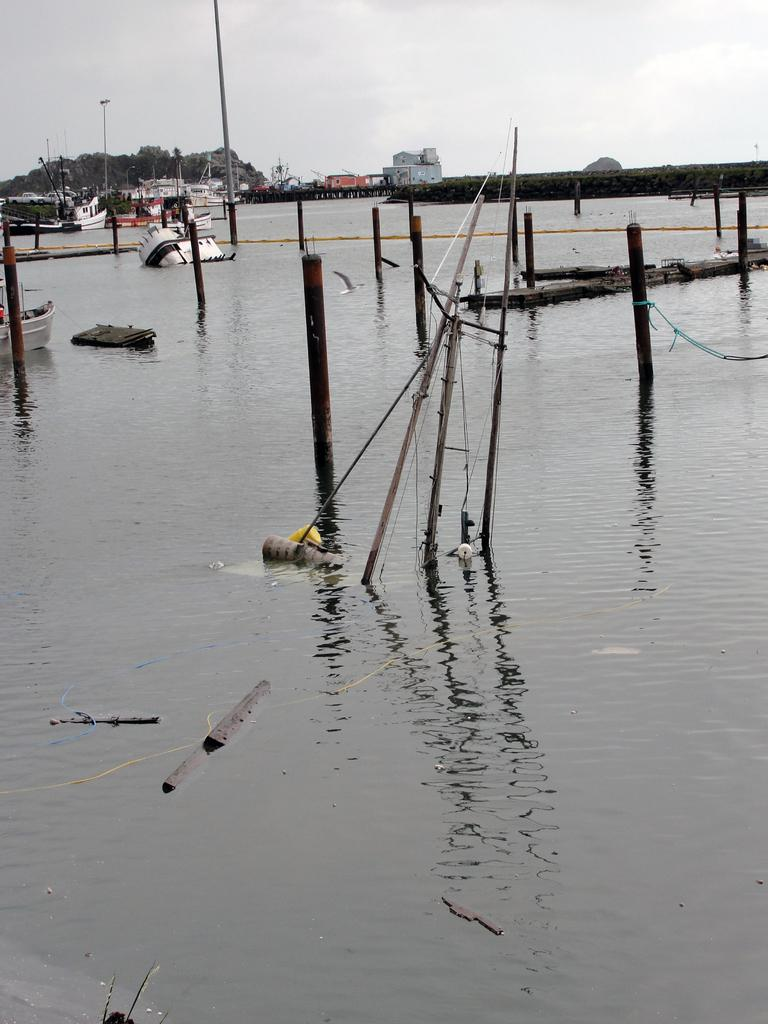What is present in the front of the image? There is water in the front of the image. What can be seen in the background of the image? There are boats, trees, and buildings in the background of the image. What is visible in the sky in the image? The sky is visible in the image. What flavor of toys can be seen in the image? There are no toys present in the image, so it is not possible to determine their flavor. 